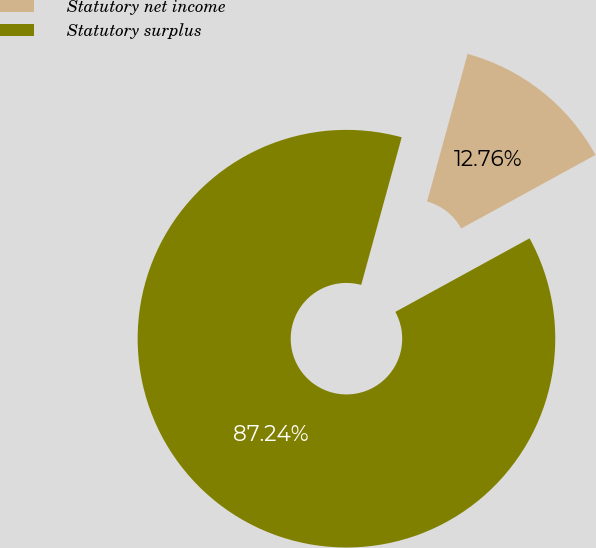Convert chart. <chart><loc_0><loc_0><loc_500><loc_500><pie_chart><fcel>Statutory net income<fcel>Statutory surplus<nl><fcel>12.76%<fcel>87.24%<nl></chart> 